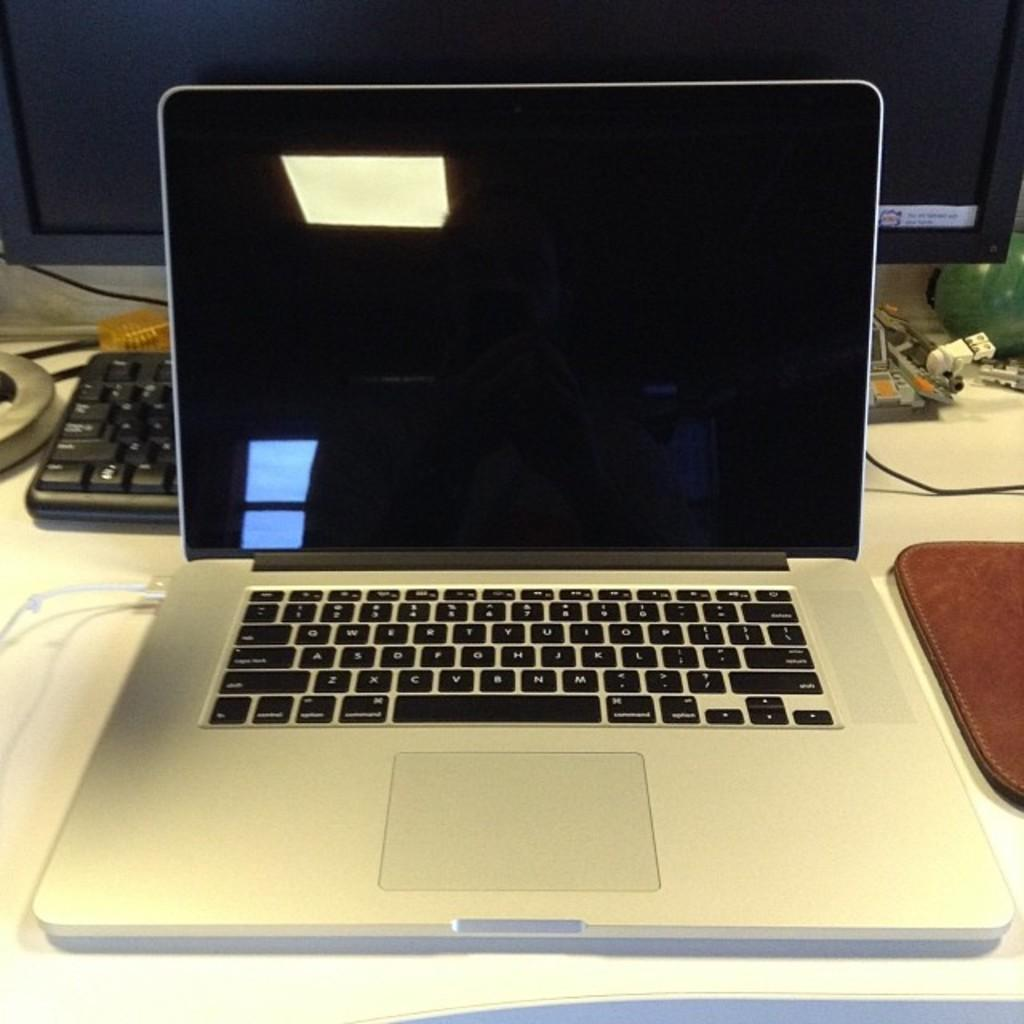<image>
Present a compact description of the photo's key features. An open white laptop has blue reflecting off the screen above the escape key. 